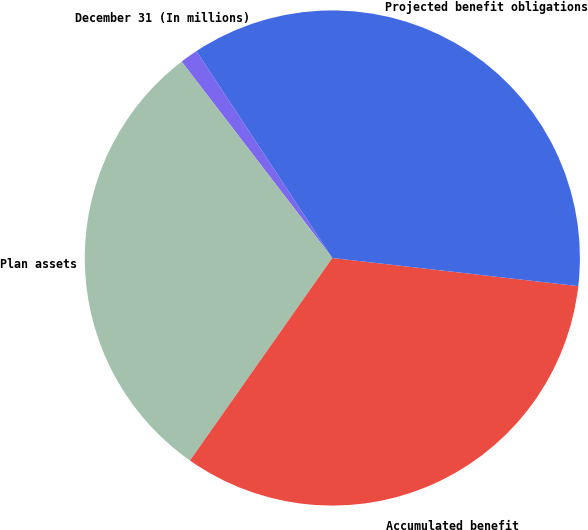Convert chart. <chart><loc_0><loc_0><loc_500><loc_500><pie_chart><fcel>December 31 (In millions)<fcel>Plan assets<fcel>Accumulated benefit<fcel>Projected benefit obligations<nl><fcel>1.17%<fcel>29.83%<fcel>32.94%<fcel>36.06%<nl></chart> 